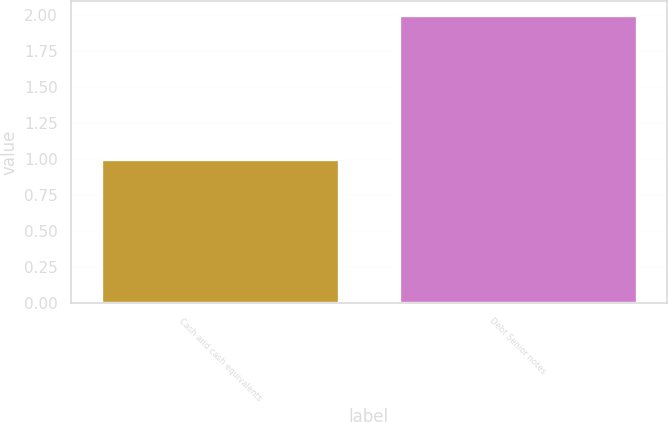Convert chart to OTSL. <chart><loc_0><loc_0><loc_500><loc_500><bar_chart><fcel>Cash and cash equivalents<fcel>Debt Senior notes<nl><fcel>1<fcel>2<nl></chart> 